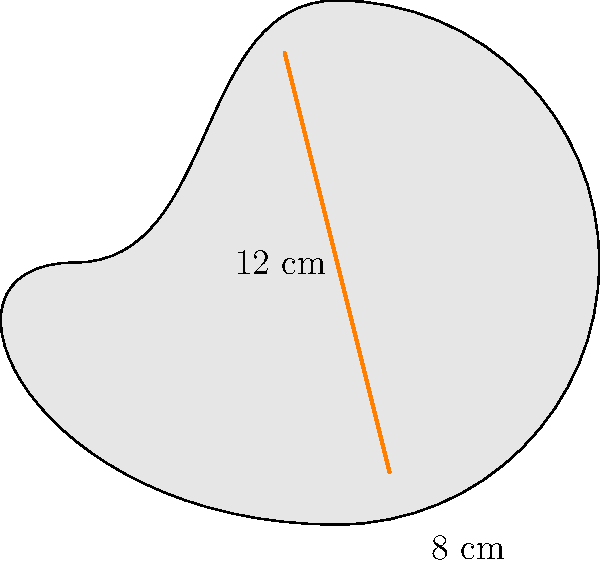A food blogger designs a carrot-shaped plate for their unique dining set. The plate's shape can be approximated by two semicircles connected by straight sides, as shown in the diagram. If the plate is 8 cm wide at its widest point and 12 cm long, what is the surface area of the plate in square centimeters? Round your answer to the nearest whole number. To find the surface area of the carrot-shaped plate, we'll follow these steps:

1) The plate consists of two semicircles (top and bottom) and a rectangle (middle).

2) Calculate the radius of the semicircles:
   Radius (r) = Width / 2 = 8 cm / 2 = 4 cm

3) Calculate the area of one semicircle:
   Area of semicircle = $\frac{1}{2} \pi r^2 = \frac{1}{2} \pi (4\text{ cm})^2 = 8\pi\text{ cm}^2$

4) Calculate the height of the rectangle:
   Height = Total length - Diameter of circle
   = 12 cm - 8 cm = 4 cm

5) Calculate the area of the rectangle:
   Area of rectangle = Width × Height = 8 cm × 4 cm = 32 cm²

6) Total surface area:
   Total Area = 2 × (Area of semicircle) + Area of rectangle
   = $2(8\pi\text{ cm}^2) + 32\text{ cm}^2$
   = $16\pi\text{ cm}^2 + 32\text{ cm}^2$
   = $16(3.14159...)\text{ cm}^2 + 32\text{ cm}^2$
   = $50.27\text{ cm}^2 + 32\text{ cm}^2$
   = $82.27\text{ cm}^2$

7) Rounding to the nearest whole number:
   $82.27\text{ cm}^2 \approx 82\text{ cm}^2$
Answer: 82 cm² 